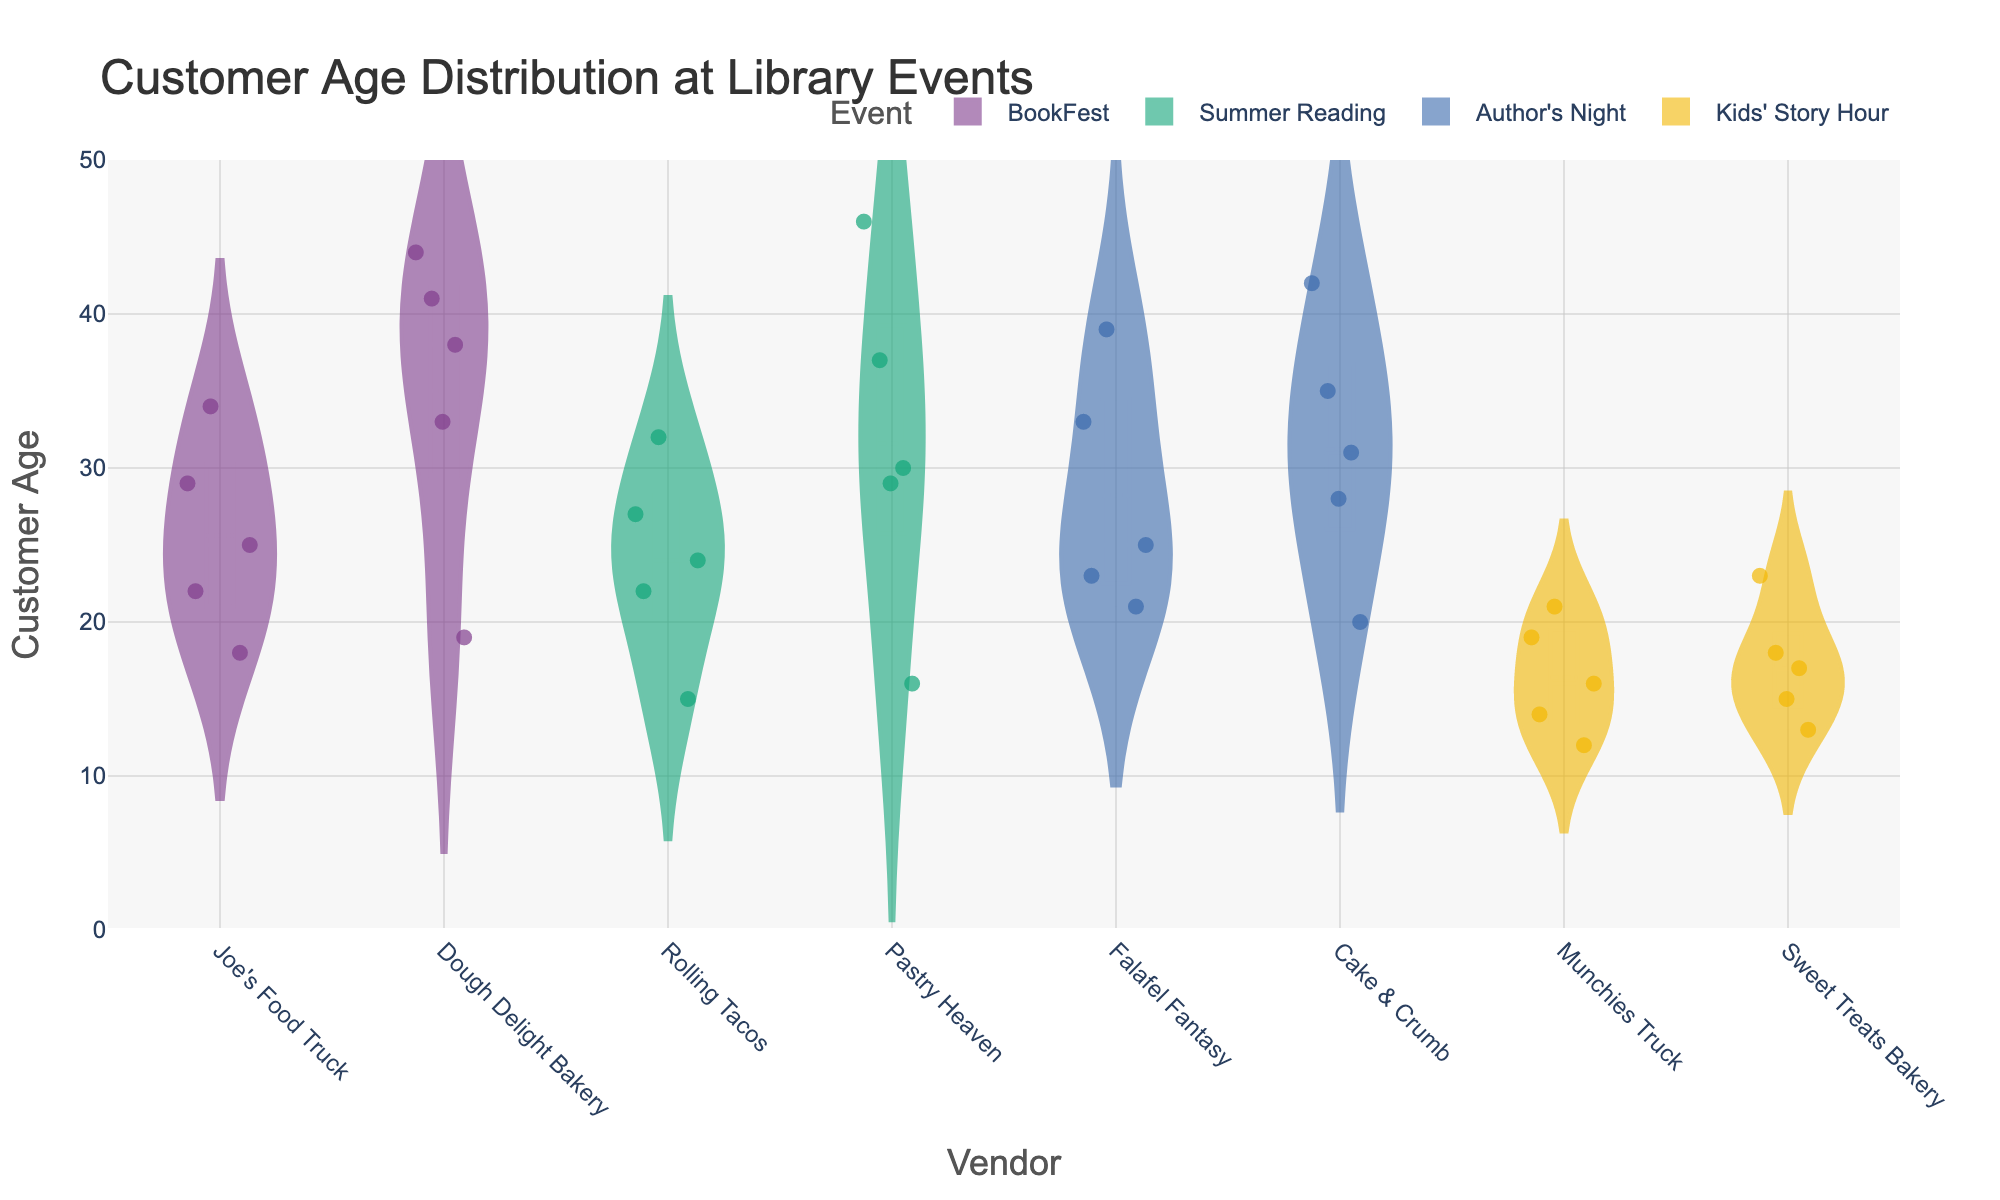What is the title of the chart? The title is displayed at the top of the chart, indicating what the figure represents.
Answer: Customer Age Distribution at Library Events Which event has the youngest median customer age? Look for the event where the box inside the violin plot is located lowest on the y-axis.
Answer: Kids' Story Hour How many different vendors participated in 'BookFest'? Count the number of different x-axis labels under the 'BookFest' condition.
Answer: 2 Between 'Pastry Heaven' and 'Rolling Tacos', which vendor has a higher average customer age in the 'Summer Reading' event? Compare the positions of the mean lines visible inside the violin plots for both vendors at the 'Summer Reading' event.
Answer: Pastry Heaven What is the range of customer ages for 'Rolling Tacos' during the 'Summer Reading' event? Look for the spread of the jittered points and the range of the violin plot on the y-axis.
Answer: 15 to 32 Which event shows the widest range of customer ages? Determine which event has the violin plot stretching the furthest from top to bottom on the y-axis.
Answer: Author's Night Between 'Joe's Food Truck' and 'Dough Delight Bakery', which vendor attracts older customers on average during the 'BookFest' event? Compare the locations of the mean lines in the violin plots under 'Joe's Food Truck' and 'Dough Delight Bakery' for the 'BookFest' event.
Answer: Dough Delight Bakery What is the approximate median customer age for 'Munchies Truck' during 'Kids' Story Hour'? Locate the middle line within the box of the violin plot for 'Munchies Truck' under 'Kids' Story Hour'.
Answer: 16 For 'Author's Night', which vendor has a more varied customer age range, 'Falafel Fantasy' or 'Cake & Crumb'? Observe which vendor's violin plot spans a larger range on the y-axis.
Answer: Cake & Crumb Does 'BookFest' have any vendors with customer ages below 20? Look for jittered points or portions of the violin plots that fall below 20 on the y-axis for vendors in 'BookFest'.
Answer: Yes 